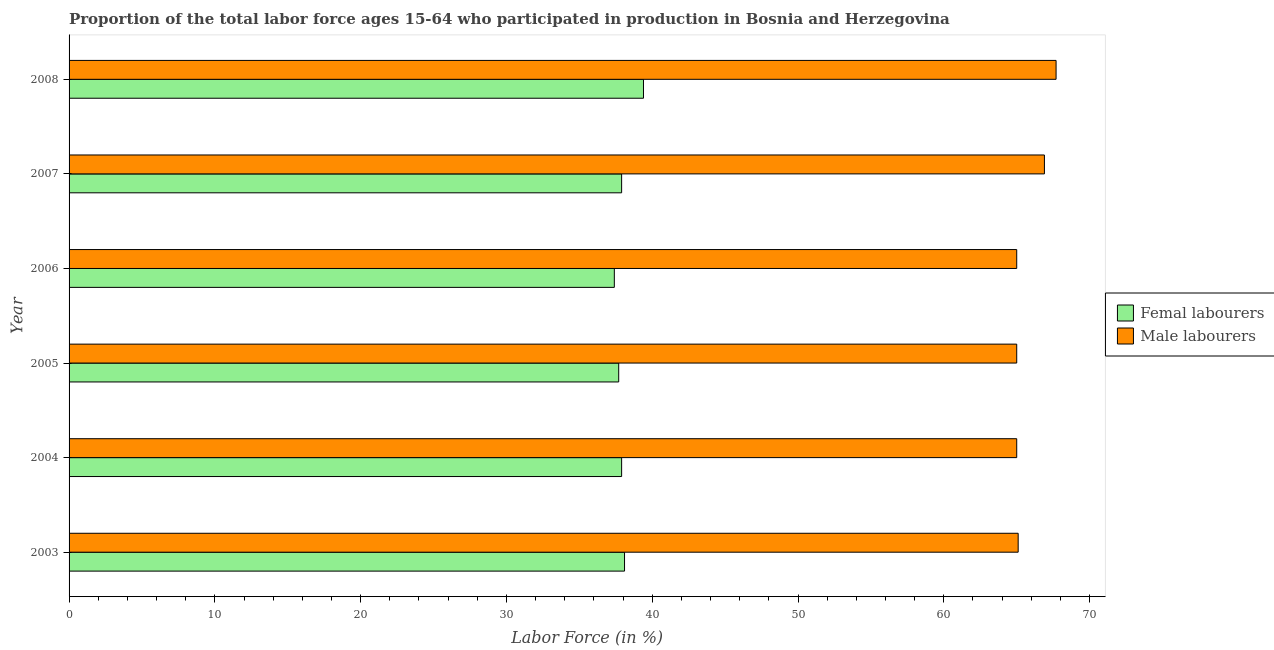Are the number of bars on each tick of the Y-axis equal?
Give a very brief answer. Yes. How many bars are there on the 5th tick from the top?
Your answer should be compact. 2. What is the label of the 1st group of bars from the top?
Provide a short and direct response. 2008. In how many cases, is the number of bars for a given year not equal to the number of legend labels?
Keep it short and to the point. 0. What is the percentage of female labor force in 2008?
Keep it short and to the point. 39.4. Across all years, what is the maximum percentage of male labour force?
Your answer should be compact. 67.7. What is the total percentage of female labor force in the graph?
Your response must be concise. 228.4. What is the difference between the percentage of female labor force in 2005 and the percentage of male labour force in 2007?
Keep it short and to the point. -29.2. What is the average percentage of male labour force per year?
Provide a succinct answer. 65.78. In the year 2005, what is the difference between the percentage of female labor force and percentage of male labour force?
Your response must be concise. -27.3. In how many years, is the percentage of male labour force greater than 52 %?
Your answer should be very brief. 6. What is the ratio of the percentage of female labor force in 2004 to that in 2007?
Your answer should be very brief. 1. Is the percentage of male labour force in 2004 less than that in 2005?
Offer a very short reply. No. In how many years, is the percentage of female labor force greater than the average percentage of female labor force taken over all years?
Ensure brevity in your answer.  2. What does the 1st bar from the top in 2008 represents?
Provide a succinct answer. Male labourers. What does the 2nd bar from the bottom in 2008 represents?
Provide a short and direct response. Male labourers. How many years are there in the graph?
Your answer should be very brief. 6. Are the values on the major ticks of X-axis written in scientific E-notation?
Offer a terse response. No. Does the graph contain grids?
Keep it short and to the point. No. How are the legend labels stacked?
Your answer should be compact. Vertical. What is the title of the graph?
Provide a short and direct response. Proportion of the total labor force ages 15-64 who participated in production in Bosnia and Herzegovina. Does "Private consumption" appear as one of the legend labels in the graph?
Make the answer very short. No. What is the label or title of the X-axis?
Your answer should be very brief. Labor Force (in %). What is the Labor Force (in %) of Femal labourers in 2003?
Make the answer very short. 38.1. What is the Labor Force (in %) of Male labourers in 2003?
Keep it short and to the point. 65.1. What is the Labor Force (in %) of Femal labourers in 2004?
Give a very brief answer. 37.9. What is the Labor Force (in %) in Male labourers in 2004?
Provide a succinct answer. 65. What is the Labor Force (in %) in Femal labourers in 2005?
Keep it short and to the point. 37.7. What is the Labor Force (in %) in Male labourers in 2005?
Your answer should be very brief. 65. What is the Labor Force (in %) of Femal labourers in 2006?
Make the answer very short. 37.4. What is the Labor Force (in %) of Male labourers in 2006?
Your answer should be very brief. 65. What is the Labor Force (in %) of Femal labourers in 2007?
Offer a very short reply. 37.9. What is the Labor Force (in %) in Male labourers in 2007?
Your answer should be very brief. 66.9. What is the Labor Force (in %) in Femal labourers in 2008?
Ensure brevity in your answer.  39.4. What is the Labor Force (in %) in Male labourers in 2008?
Give a very brief answer. 67.7. Across all years, what is the maximum Labor Force (in %) of Femal labourers?
Your response must be concise. 39.4. Across all years, what is the maximum Labor Force (in %) of Male labourers?
Offer a terse response. 67.7. Across all years, what is the minimum Labor Force (in %) of Femal labourers?
Make the answer very short. 37.4. What is the total Labor Force (in %) in Femal labourers in the graph?
Provide a succinct answer. 228.4. What is the total Labor Force (in %) of Male labourers in the graph?
Offer a very short reply. 394.7. What is the difference between the Labor Force (in %) of Femal labourers in 2003 and that in 2005?
Your response must be concise. 0.4. What is the difference between the Labor Force (in %) in Male labourers in 2003 and that in 2006?
Ensure brevity in your answer.  0.1. What is the difference between the Labor Force (in %) in Male labourers in 2003 and that in 2007?
Provide a succinct answer. -1.8. What is the difference between the Labor Force (in %) of Male labourers in 2003 and that in 2008?
Provide a short and direct response. -2.6. What is the difference between the Labor Force (in %) of Femal labourers in 2004 and that in 2005?
Give a very brief answer. 0.2. What is the difference between the Labor Force (in %) of Male labourers in 2004 and that in 2006?
Provide a succinct answer. 0. What is the difference between the Labor Force (in %) in Male labourers in 2005 and that in 2006?
Your answer should be compact. 0. What is the difference between the Labor Force (in %) in Femal labourers in 2005 and that in 2007?
Your answer should be compact. -0.2. What is the difference between the Labor Force (in %) of Femal labourers in 2005 and that in 2008?
Offer a very short reply. -1.7. What is the difference between the Labor Force (in %) in Male labourers in 2005 and that in 2008?
Provide a short and direct response. -2.7. What is the difference between the Labor Force (in %) in Male labourers in 2006 and that in 2008?
Give a very brief answer. -2.7. What is the difference between the Labor Force (in %) of Femal labourers in 2007 and that in 2008?
Your response must be concise. -1.5. What is the difference between the Labor Force (in %) in Femal labourers in 2003 and the Labor Force (in %) in Male labourers in 2004?
Keep it short and to the point. -26.9. What is the difference between the Labor Force (in %) of Femal labourers in 2003 and the Labor Force (in %) of Male labourers in 2005?
Provide a short and direct response. -26.9. What is the difference between the Labor Force (in %) in Femal labourers in 2003 and the Labor Force (in %) in Male labourers in 2006?
Ensure brevity in your answer.  -26.9. What is the difference between the Labor Force (in %) of Femal labourers in 2003 and the Labor Force (in %) of Male labourers in 2007?
Make the answer very short. -28.8. What is the difference between the Labor Force (in %) of Femal labourers in 2003 and the Labor Force (in %) of Male labourers in 2008?
Ensure brevity in your answer.  -29.6. What is the difference between the Labor Force (in %) of Femal labourers in 2004 and the Labor Force (in %) of Male labourers in 2005?
Your answer should be compact. -27.1. What is the difference between the Labor Force (in %) in Femal labourers in 2004 and the Labor Force (in %) in Male labourers in 2006?
Provide a succinct answer. -27.1. What is the difference between the Labor Force (in %) in Femal labourers in 2004 and the Labor Force (in %) in Male labourers in 2008?
Provide a succinct answer. -29.8. What is the difference between the Labor Force (in %) of Femal labourers in 2005 and the Labor Force (in %) of Male labourers in 2006?
Your response must be concise. -27.3. What is the difference between the Labor Force (in %) of Femal labourers in 2005 and the Labor Force (in %) of Male labourers in 2007?
Ensure brevity in your answer.  -29.2. What is the difference between the Labor Force (in %) of Femal labourers in 2005 and the Labor Force (in %) of Male labourers in 2008?
Provide a short and direct response. -30. What is the difference between the Labor Force (in %) of Femal labourers in 2006 and the Labor Force (in %) of Male labourers in 2007?
Provide a short and direct response. -29.5. What is the difference between the Labor Force (in %) in Femal labourers in 2006 and the Labor Force (in %) in Male labourers in 2008?
Provide a succinct answer. -30.3. What is the difference between the Labor Force (in %) of Femal labourers in 2007 and the Labor Force (in %) of Male labourers in 2008?
Your answer should be very brief. -29.8. What is the average Labor Force (in %) of Femal labourers per year?
Offer a very short reply. 38.07. What is the average Labor Force (in %) of Male labourers per year?
Make the answer very short. 65.78. In the year 2004, what is the difference between the Labor Force (in %) of Femal labourers and Labor Force (in %) of Male labourers?
Give a very brief answer. -27.1. In the year 2005, what is the difference between the Labor Force (in %) in Femal labourers and Labor Force (in %) in Male labourers?
Keep it short and to the point. -27.3. In the year 2006, what is the difference between the Labor Force (in %) in Femal labourers and Labor Force (in %) in Male labourers?
Ensure brevity in your answer.  -27.6. In the year 2008, what is the difference between the Labor Force (in %) in Femal labourers and Labor Force (in %) in Male labourers?
Make the answer very short. -28.3. What is the ratio of the Labor Force (in %) of Femal labourers in 2003 to that in 2004?
Offer a terse response. 1.01. What is the ratio of the Labor Force (in %) in Male labourers in 2003 to that in 2004?
Ensure brevity in your answer.  1. What is the ratio of the Labor Force (in %) of Femal labourers in 2003 to that in 2005?
Your answer should be compact. 1.01. What is the ratio of the Labor Force (in %) in Femal labourers in 2003 to that in 2006?
Make the answer very short. 1.02. What is the ratio of the Labor Force (in %) in Male labourers in 2003 to that in 2006?
Offer a very short reply. 1. What is the ratio of the Labor Force (in %) in Femal labourers in 2003 to that in 2007?
Ensure brevity in your answer.  1.01. What is the ratio of the Labor Force (in %) in Male labourers in 2003 to that in 2007?
Ensure brevity in your answer.  0.97. What is the ratio of the Labor Force (in %) in Male labourers in 2003 to that in 2008?
Your answer should be compact. 0.96. What is the ratio of the Labor Force (in %) of Femal labourers in 2004 to that in 2005?
Provide a short and direct response. 1.01. What is the ratio of the Labor Force (in %) in Male labourers in 2004 to that in 2005?
Offer a very short reply. 1. What is the ratio of the Labor Force (in %) in Femal labourers in 2004 to that in 2006?
Make the answer very short. 1.01. What is the ratio of the Labor Force (in %) of Male labourers in 2004 to that in 2006?
Your answer should be very brief. 1. What is the ratio of the Labor Force (in %) in Male labourers in 2004 to that in 2007?
Keep it short and to the point. 0.97. What is the ratio of the Labor Force (in %) of Femal labourers in 2004 to that in 2008?
Your answer should be very brief. 0.96. What is the ratio of the Labor Force (in %) in Male labourers in 2004 to that in 2008?
Provide a short and direct response. 0.96. What is the ratio of the Labor Force (in %) of Femal labourers in 2005 to that in 2007?
Offer a terse response. 0.99. What is the ratio of the Labor Force (in %) in Male labourers in 2005 to that in 2007?
Keep it short and to the point. 0.97. What is the ratio of the Labor Force (in %) in Femal labourers in 2005 to that in 2008?
Provide a short and direct response. 0.96. What is the ratio of the Labor Force (in %) of Male labourers in 2005 to that in 2008?
Your response must be concise. 0.96. What is the ratio of the Labor Force (in %) in Male labourers in 2006 to that in 2007?
Provide a succinct answer. 0.97. What is the ratio of the Labor Force (in %) in Femal labourers in 2006 to that in 2008?
Offer a terse response. 0.95. What is the ratio of the Labor Force (in %) of Male labourers in 2006 to that in 2008?
Keep it short and to the point. 0.96. What is the ratio of the Labor Force (in %) in Femal labourers in 2007 to that in 2008?
Ensure brevity in your answer.  0.96. What is the ratio of the Labor Force (in %) in Male labourers in 2007 to that in 2008?
Ensure brevity in your answer.  0.99. What is the difference between the highest and the second highest Labor Force (in %) in Femal labourers?
Your answer should be very brief. 1.3. What is the difference between the highest and the second highest Labor Force (in %) of Male labourers?
Keep it short and to the point. 0.8. 